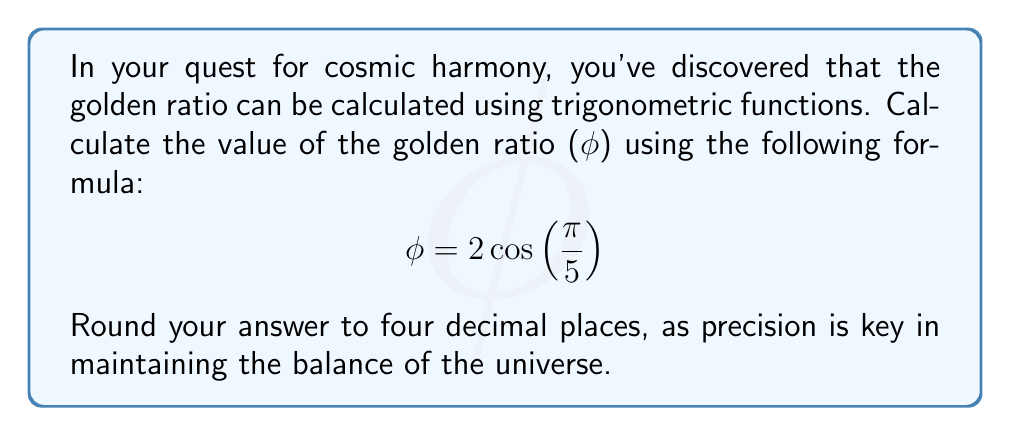Can you solve this math problem? To calculate the golden ratio using the given trigonometric formula, we'll follow these steps:

1. Recall the formula: $\phi = 2 \cos\left(\frac{\pi}{5}\right)$

2. First, we need to calculate $\frac{\pi}{5}$:
   $\frac{\pi}{5} \approx 0.6283185307179586$

3. Now, we need to find the cosine of this value:
   $\cos\left(\frac{\pi}{5}\right) \approx 0.8090169943749475$

4. Finally, we multiply this result by 2:
   $2 \cos\left(\frac{\pi}{5}\right) \approx 2 \times 0.8090169943749475 \approx 1.618033988749895$

5. Rounding to four decimal places:
   $\phi \approx 1.6180$

This result aligns with the well-known value of the golden ratio, often symbolized by φ (phi). The golden ratio is an irrational number that appears in various aspects of nature, art, and architecture, and is considered by many to represent divine proportion and cosmic harmony.
Answer: $\phi \approx 1.6180$ 